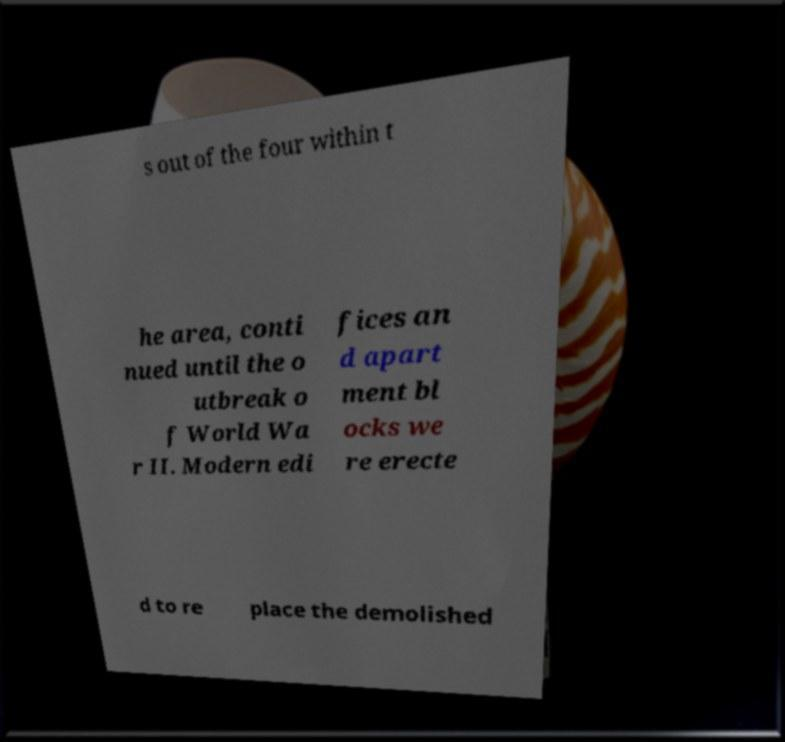For documentation purposes, I need the text within this image transcribed. Could you provide that? s out of the four within t he area, conti nued until the o utbreak o f World Wa r II. Modern edi fices an d apart ment bl ocks we re erecte d to re place the demolished 